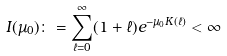<formula> <loc_0><loc_0><loc_500><loc_500>I ( \mu _ { 0 } ) \colon = \sum _ { \ell = 0 } ^ { \infty } ( 1 + \ell ) e ^ { - \mu _ { 0 } K ( \ell ) } < \infty</formula> 